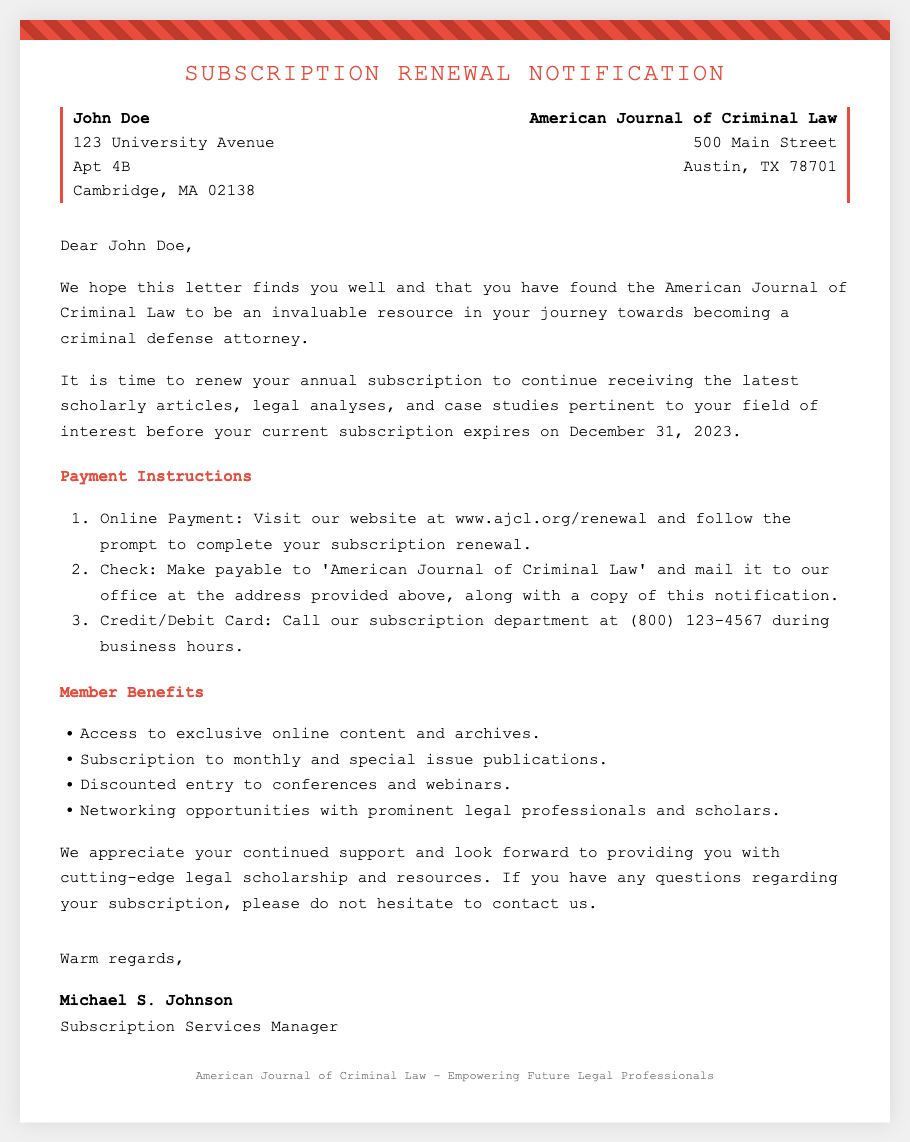What is the name of the journal? The name of the journal is mentioned in the header and sender address part of the document.
Answer: American Journal of Criminal Law Who is the recipient of the subscription renewal notification? The recipient's name is presented at the beginning of the document, at the address section.
Answer: John Doe What is the renewal deadline for the subscription? The document specifies this date clearly in the content section.
Answer: December 31, 2023 What payment method requires mailing a check? The instructional list in the payment section outlines different payment methods.
Answer: Check How many member benefits are listed in the document? The member benefits section outlines different advantages for subscribers.
Answer: Four What is the website for online payment? The URL for online payment is given in the payment instructions section.
Answer: www.ajcl.org/renewal Who signed the letter? The name of the person who signed the letter is found in the signature section.
Answer: Michael S. Johnson What department can you call for subscription inquiries? The subscription department is mentioned in the payment instructions with a phone number.
Answer: Subscription department What color is used for the header text? The header text color can be observed directly in the design of the document.
Answer: #e74c3c 